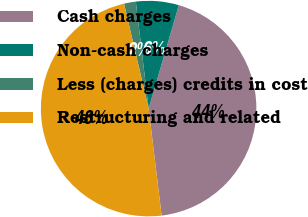Convert chart. <chart><loc_0><loc_0><loc_500><loc_500><pie_chart><fcel>Cash charges<fcel>Non-cash charges<fcel>Less (charges) credits in cost<fcel>Restructuring and related<nl><fcel>43.56%<fcel>6.42%<fcel>1.77%<fcel>48.26%<nl></chart> 